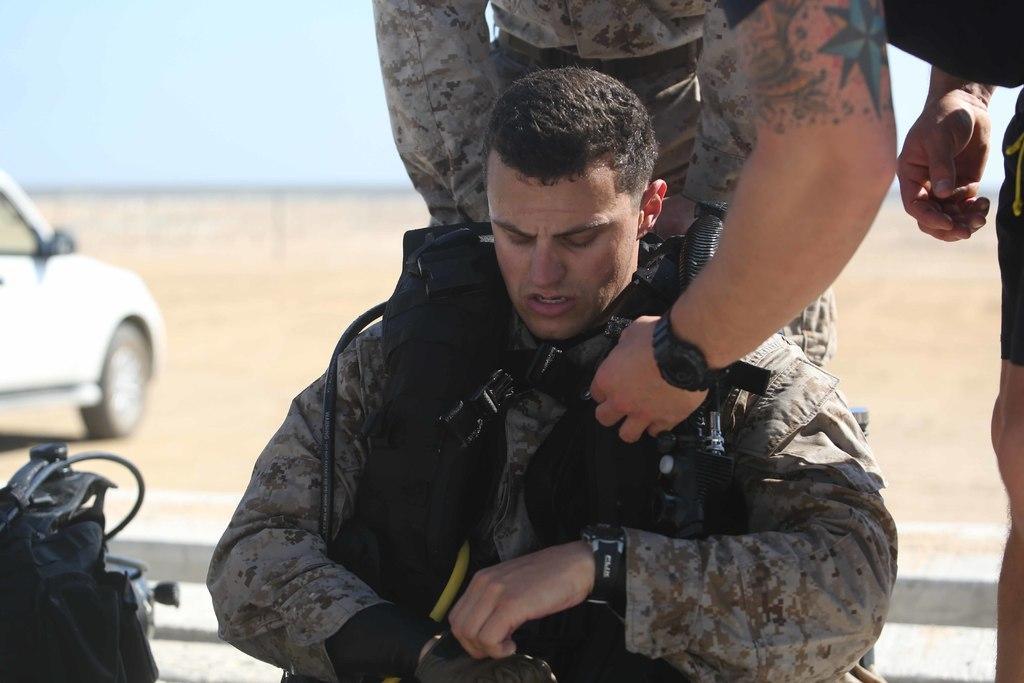Could you give a brief overview of what you see in this image? In this image I can see few persons wearing uniforms. In the background I can see the ground, a vehicle on the ground and the sky. 